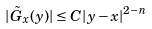Convert formula to latex. <formula><loc_0><loc_0><loc_500><loc_500>| \tilde { G } _ { x } ( y ) | \leq C | y - x | ^ { 2 - n }</formula> 